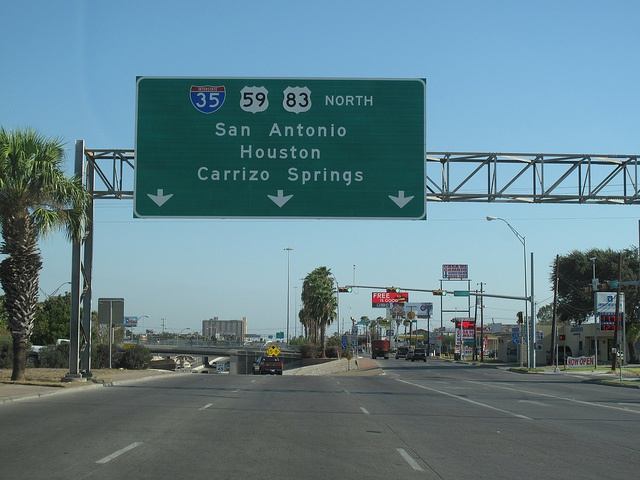Describe the objects in this image and their specific colors. I can see truck in gray, black, and purple tones, truck in gray, black, and maroon tones, truck in gray, black, and purple tones, car in gray, black, and purple tones, and car in gray, black, purple, and darkblue tones in this image. 